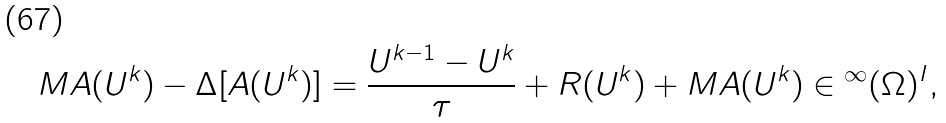<formula> <loc_0><loc_0><loc_500><loc_500>M A ( U ^ { k } ) - \Delta [ A ( U ^ { k } ) ] = \frac { U ^ { k - 1 } - U ^ { k } } { \tau } + R ( U ^ { k } ) + M A ( U ^ { k } ) \in \L ^ { \infty } ( \Omega ) ^ { I } ,</formula> 